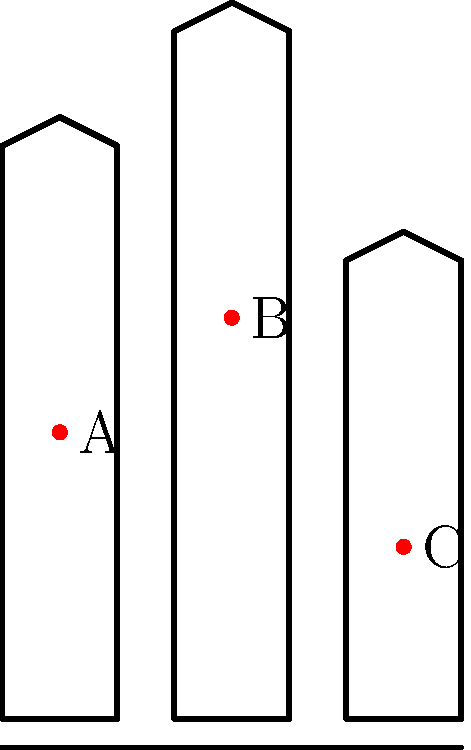In the diagram above, three medieval sword designs are shown with their respective centers of mass marked as points A, B, and C. Which sword design is likely to be the most stable and easiest to control during combat? To determine which sword design is the most stable and easiest to control, we need to consider the position of the center of mass for each sword:

1. Sword 1 (point A): The center of mass is located at the midpoint of the blade.
2. Sword 2 (point B): The center of mass is higher up on the blade, closer to the hilt.
3. Sword 3 (point C): The center of mass is lower on the blade, closer to the tip.

Step-by-step analysis:

1. A lower center of mass generally provides better stability and control.
2. A center of mass closer to the hilt allows for easier manipulation and quicker movements.
3. Sword 1 has a balanced design, but the center of mass is still relatively high.
4. Sword 2 has the highest center of mass, which would make it the least stable and hardest to control.
5. Sword 3 has the lowest center of mass, closest to the wielder's hand.

The lower center of mass in Sword 3 (point C) provides several advantages:
- Better balance and stability during swings
- Easier to change direction mid-swing
- More control over the tip of the sword
- Less fatigue for the wielder during extended use

These factors make Sword 3 the most stable and easiest to control during combat.
Answer: Sword 3 (point C) 